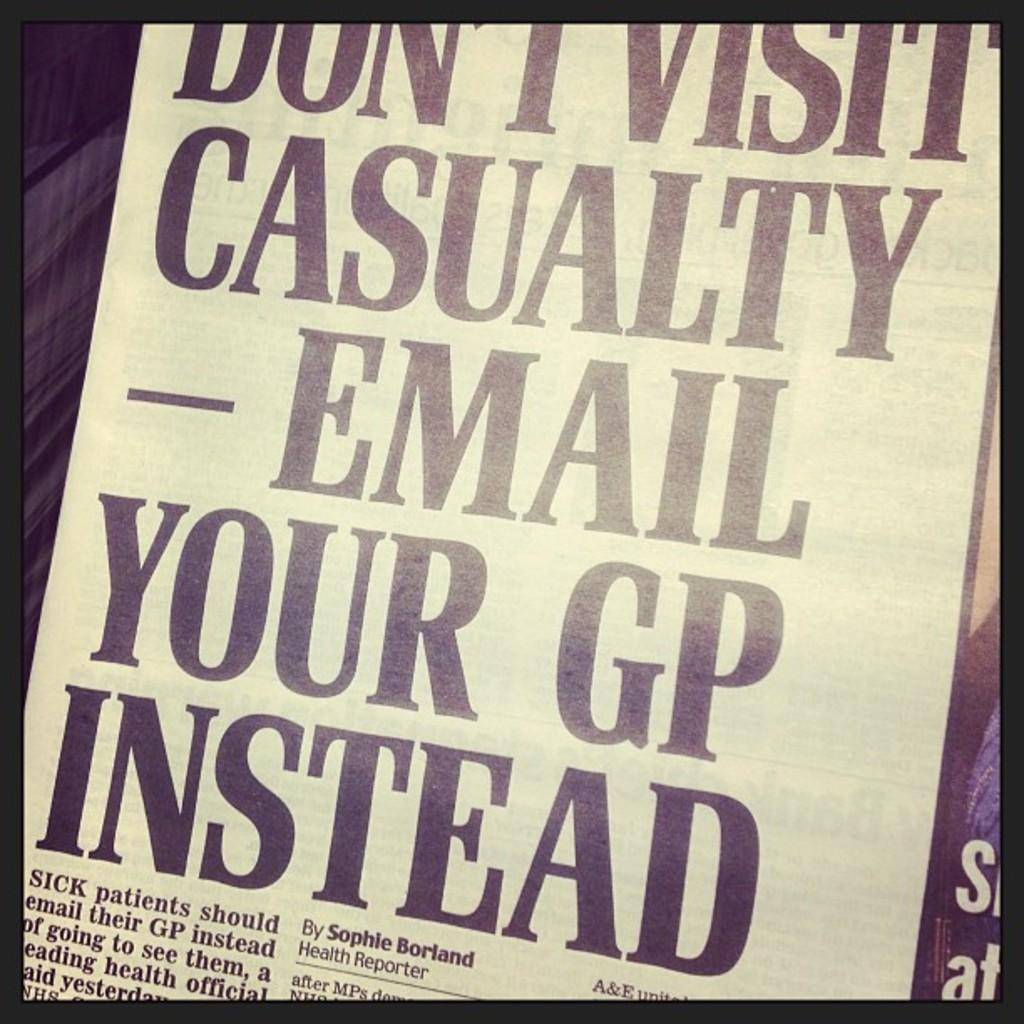<image>
Create a compact narrative representing the image presented. A newspaper headline telling people to email their GPs instead of visiting. 